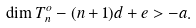Convert formula to latex. <formula><loc_0><loc_0><loc_500><loc_500>\dim T _ { n } ^ { o } - ( n + 1 ) d + e > - a .</formula> 